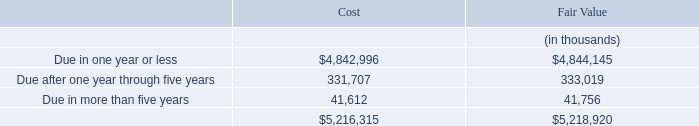The amortized cost and fair value of cash equivalents, investments, and restricted investments with contractual maturities as of June 30, 2019, are as follows:
The Company has the ability, if necessary, to liquidate its investments in order to meet the Company’s liquidity needs in the next 12 months. Accordingly, those investments with contractual maturities greater than 12 months from the date of purchase nonetheless are classified as short-term on the accompanying Consolidated Balance Sheets.
What is the amount of fair value of cash equivalents, investments, and restricted investments with contractual maturities as of June 30, 2019 that is due in more than five years?
Answer scale should be: thousand. 41,612. What is the amount of amortized cost of cash equivalents, investments, and restricted investments with contractual maturities as of June 30, 2019 that is due in one year or less?
Answer scale should be: thousand. $4,842,996. What is the amount of fair value of cash equivalents, investments, and restricted investments with contractual maturities as of June 30, 2019 that is due after one year through five years?
Answer scale should be: thousand. 333,019. What is the percentage of fair value of cash equivalents, investments, and restricted investments with contractual maturities that is due in more than five years in the total fair value?
Answer scale should be: percent. 41,756/5,218,920
Answer: 0.8. What is the percentage of amortized cost of cash equivalents, investments, and restricted investments with contractual maturities that is due in more than five year in the total cost?
Answer scale should be: percent. 41,612/5,216,315
Answer: 0.8. Which measurement of cash equivalents, investments, and restricted investments with contractual maturities has a higher total amount? Find the measurement with the higher total amount
Answer: fair value. 